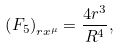Convert formula to latex. <formula><loc_0><loc_0><loc_500><loc_500>\left ( F _ { 5 } \right ) _ { r x ^ { \mu } } = \frac { 4 r ^ { 3 } } { R ^ { 4 } } ,</formula> 